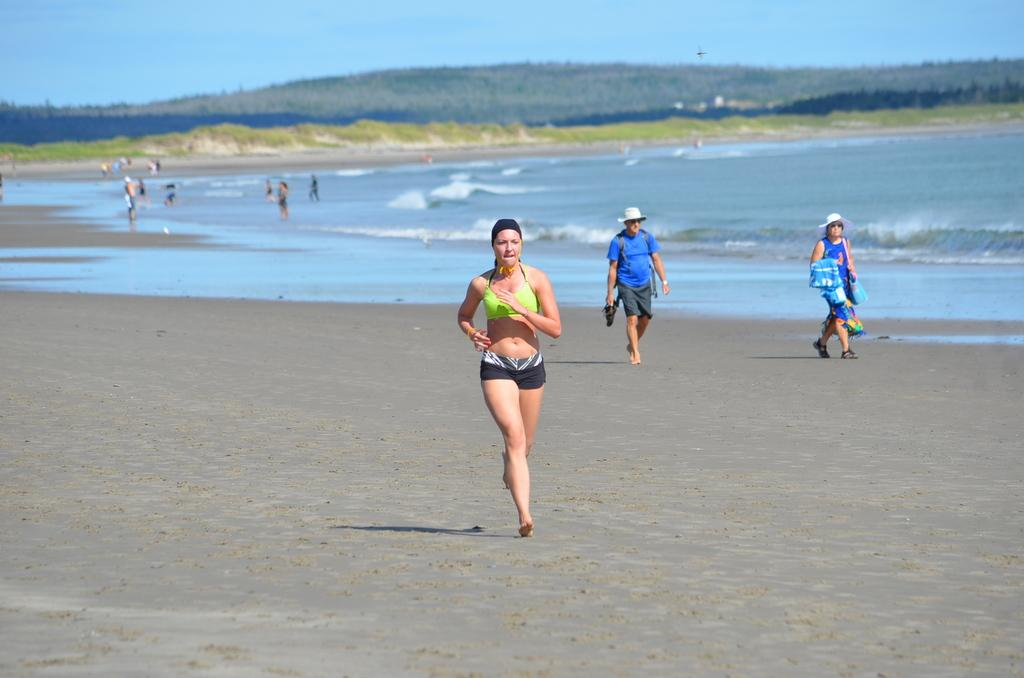What are the people in the image doing? The people in the image are walking. What natural element is visible in the image? Water is visible in the image. What part of the environment can be seen in the image? The sky is visible in the image. What type of ring can be seen on the coat of the person in the image? There is no person wearing a coat or any ring visible in the image. 